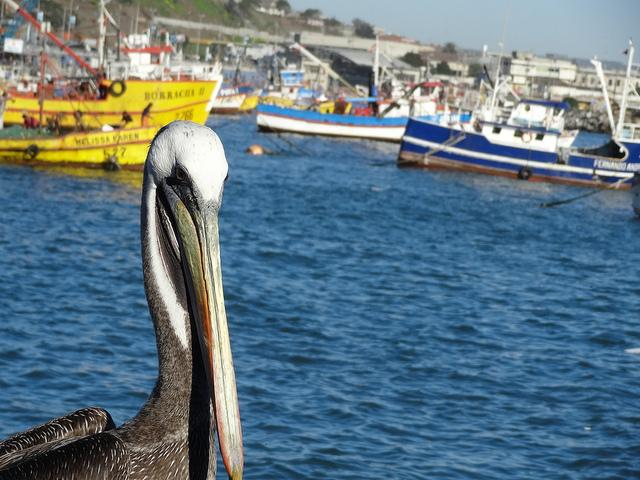On what continent was this photo most likely taken? north america 